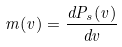Convert formula to latex. <formula><loc_0><loc_0><loc_500><loc_500>m ( v ) = \frac { { d } P _ { s } ( v ) } { { d } v }</formula> 